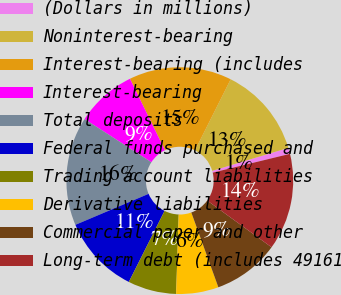<chart> <loc_0><loc_0><loc_500><loc_500><pie_chart><fcel>(Dollars in millions)<fcel>Noninterest-bearing<fcel>Interest-bearing (includes<fcel>Interest-bearing<fcel>Total deposits<fcel>Federal funds purchased and<fcel>Trading account liabilities<fcel>Derivative liabilities<fcel>Commercial paper and other<fcel>Long-term debt (includes 49161<nl><fcel>0.87%<fcel>12.93%<fcel>14.65%<fcel>8.62%<fcel>15.51%<fcel>11.21%<fcel>6.9%<fcel>6.04%<fcel>9.48%<fcel>13.79%<nl></chart> 